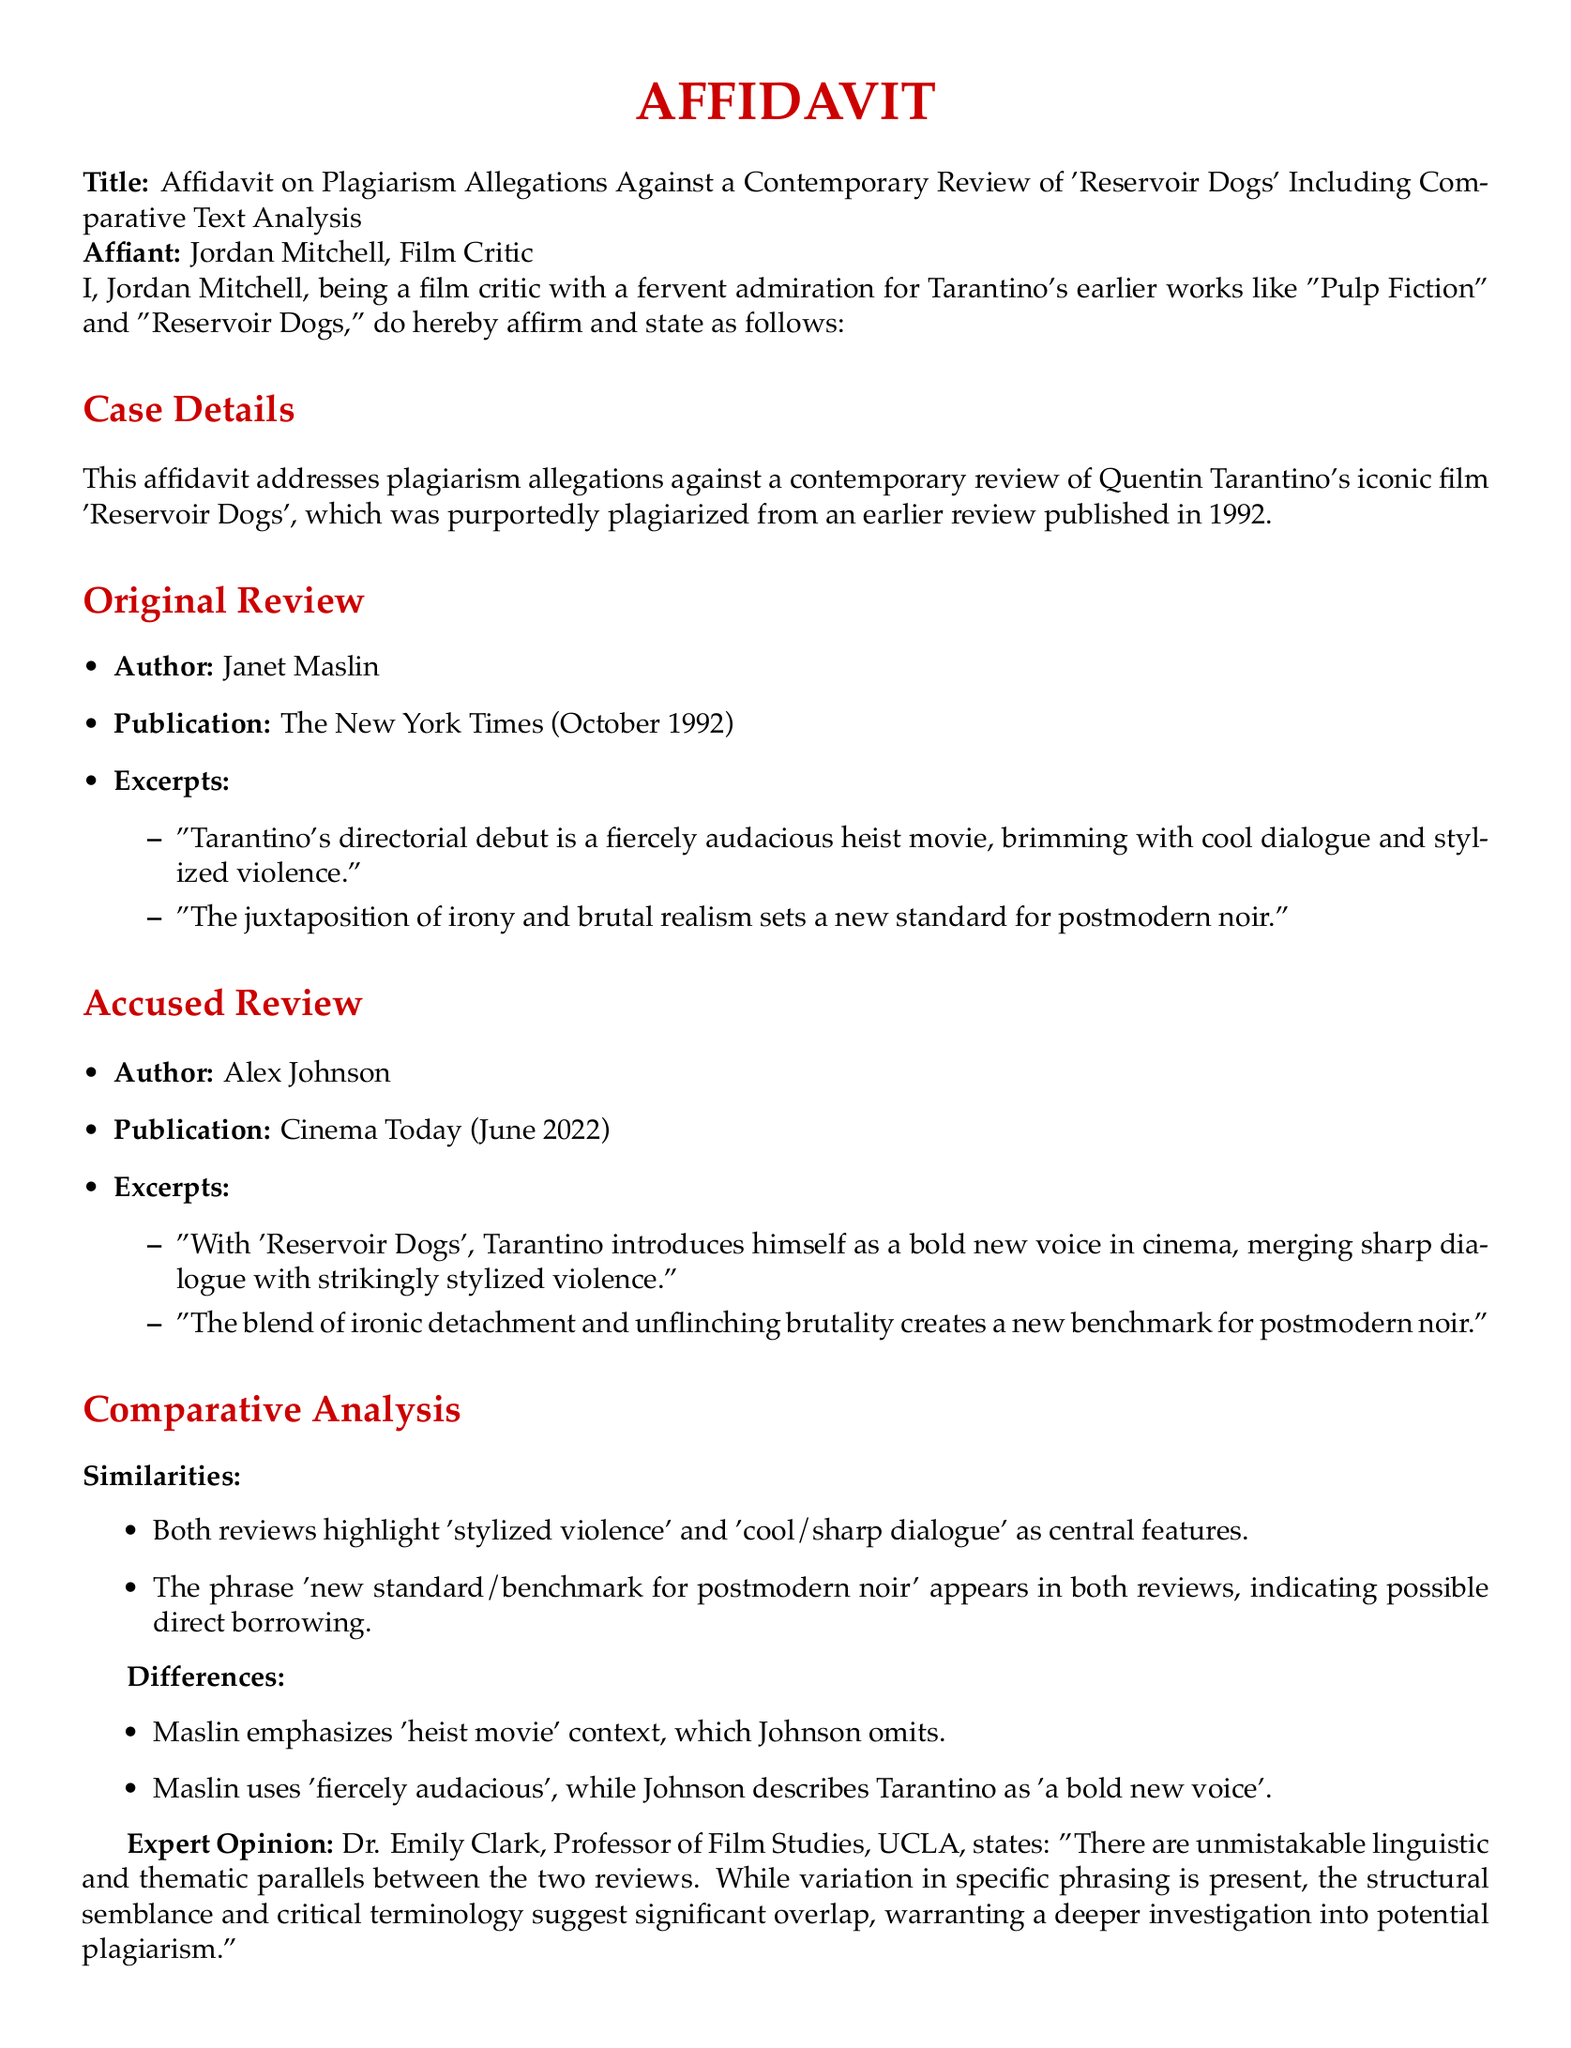what is the title of the affidavit? The title of the affidavit is stated at the beginning of the document, which addresses plagiarism allegations against a review of 'Reservoir Dogs'.
Answer: Affidavit on Plagiarism Allegations Against a Contemporary Review of 'Reservoir Dogs' Including Comparative Text Analysis who is the affiant? The affiant is the individual who provides this sworn statement, which is indicated in the document.
Answer: Jordan Mitchell what publication featured the original review? The document specifies where the original review was published, providing clear attribution.
Answer: The New York Times when was the original review published? The date of publication for the original review is given in the document.
Answer: October 1992 what phrase do both reviews use regarding postmodern noir? The related phrase that appears in both reviews signifies a common perspective on a genre element, noted in the comparative analysis section.
Answer: new standard/benchmark for postmodern noir who authored the accused review? The document identifies the author of the contemporary review being scrutinized for potentially plagiarizing content.
Answer: Alex Johnson what does Dr. Emily Clark's title indicate about her expertise? The title of Dr. Emily Clark provides insight into her qualifications relevant to the analysis of the reviews.
Answer: Professor of Film Studies what key aspect does Maslin emphasize that Johnson omits? The document outlines a difference in focus between the original and accused reviews, highlighting this particular aspect.
Answer: heist movie what is the final statement's main point? The conclusion of the affidavit underscores the affiant's commitment to ethical standards in film criticism, which is articulated in the final statement section.
Answer: necessity of upholding ethical standards in film criticism 